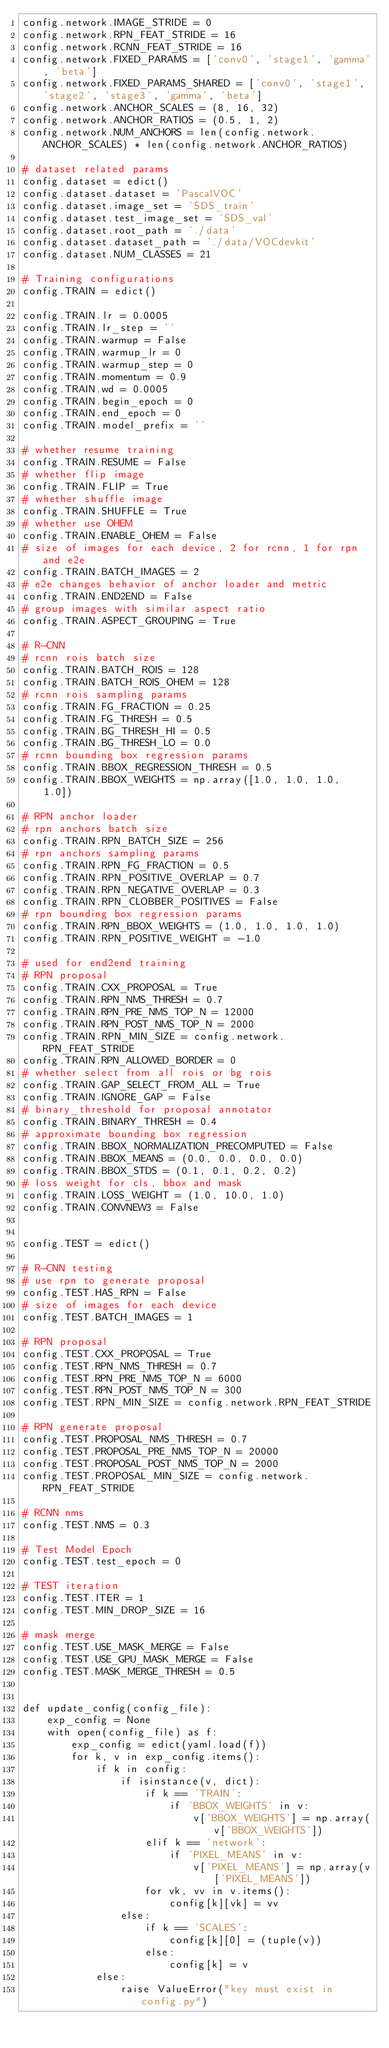<code> <loc_0><loc_0><loc_500><loc_500><_Python_>config.network.IMAGE_STRIDE = 0
config.network.RPN_FEAT_STRIDE = 16
config.network.RCNN_FEAT_STRIDE = 16
config.network.FIXED_PARAMS = ['conv0', 'stage1', 'gamma', 'beta']
config.network.FIXED_PARAMS_SHARED = ['conv0', 'stage1', 'stage2', 'stage3', 'gamma', 'beta']
config.network.ANCHOR_SCALES = (8, 16, 32)
config.network.ANCHOR_RATIOS = (0.5, 1, 2)
config.network.NUM_ANCHORS = len(config.network.ANCHOR_SCALES) * len(config.network.ANCHOR_RATIOS)

# dataset related params
config.dataset = edict()
config.dataset.dataset = 'PascalVOC'
config.dataset.image_set = 'SDS_train'
config.dataset.test_image_set = 'SDS_val'
config.dataset.root_path = './data'
config.dataset.dataset_path = './data/VOCdevkit'
config.dataset.NUM_CLASSES = 21

# Training configurations
config.TRAIN = edict()

config.TRAIN.lr = 0.0005
config.TRAIN.lr_step = ''
config.TRAIN.warmup = False
config.TRAIN.warmup_lr = 0
config.TRAIN.warmup_step = 0
config.TRAIN.momentum = 0.9
config.TRAIN.wd = 0.0005
config.TRAIN.begin_epoch = 0
config.TRAIN.end_epoch = 0
config.TRAIN.model_prefix = ''

# whether resume training
config.TRAIN.RESUME = False
# whether flip image
config.TRAIN.FLIP = True
# whether shuffle image
config.TRAIN.SHUFFLE = True
# whether use OHEM
config.TRAIN.ENABLE_OHEM = False
# size of images for each device, 2 for rcnn, 1 for rpn and e2e
config.TRAIN.BATCH_IMAGES = 2
# e2e changes behavior of anchor loader and metric
config.TRAIN.END2END = False
# group images with similar aspect ratio
config.TRAIN.ASPECT_GROUPING = True

# R-CNN
# rcnn rois batch size
config.TRAIN.BATCH_ROIS = 128
config.TRAIN.BATCH_ROIS_OHEM = 128
# rcnn rois sampling params
config.TRAIN.FG_FRACTION = 0.25
config.TRAIN.FG_THRESH = 0.5
config.TRAIN.BG_THRESH_HI = 0.5
config.TRAIN.BG_THRESH_LO = 0.0
# rcnn bounding box regression params
config.TRAIN.BBOX_REGRESSION_THRESH = 0.5
config.TRAIN.BBOX_WEIGHTS = np.array([1.0, 1.0, 1.0, 1.0])

# RPN anchor loader
# rpn anchors batch size
config.TRAIN.RPN_BATCH_SIZE = 256
# rpn anchors sampling params
config.TRAIN.RPN_FG_FRACTION = 0.5
config.TRAIN.RPN_POSITIVE_OVERLAP = 0.7
config.TRAIN.RPN_NEGATIVE_OVERLAP = 0.3
config.TRAIN.RPN_CLOBBER_POSITIVES = False
# rpn bounding box regression params
config.TRAIN.RPN_BBOX_WEIGHTS = (1.0, 1.0, 1.0, 1.0)
config.TRAIN.RPN_POSITIVE_WEIGHT = -1.0

# used for end2end training
# RPN proposal
config.TRAIN.CXX_PROPOSAL = True
config.TRAIN.RPN_NMS_THRESH = 0.7
config.TRAIN.RPN_PRE_NMS_TOP_N = 12000
config.TRAIN.RPN_POST_NMS_TOP_N = 2000
config.TRAIN.RPN_MIN_SIZE = config.network.RPN_FEAT_STRIDE
config.TRAIN.RPN_ALLOWED_BORDER = 0
# whether select from all rois or bg rois
config.TRAIN.GAP_SELECT_FROM_ALL = True
config.TRAIN.IGNORE_GAP = False
# binary_threshold for proposal annotator
config.TRAIN.BINARY_THRESH = 0.4
# approximate bounding box regression
config.TRAIN.BBOX_NORMALIZATION_PRECOMPUTED = False
config.TRAIN.BBOX_MEANS = (0.0, 0.0, 0.0, 0.0)
config.TRAIN.BBOX_STDS = (0.1, 0.1, 0.2, 0.2)
# loss weight for cls, bbox and mask
config.TRAIN.LOSS_WEIGHT = (1.0, 10.0, 1.0)
config.TRAIN.CONVNEW3 = False


config.TEST = edict()

# R-CNN testing
# use rpn to generate proposal
config.TEST.HAS_RPN = False
# size of images for each device
config.TEST.BATCH_IMAGES = 1

# RPN proposal
config.TEST.CXX_PROPOSAL = True
config.TEST.RPN_NMS_THRESH = 0.7
config.TEST.RPN_PRE_NMS_TOP_N = 6000
config.TEST.RPN_POST_NMS_TOP_N = 300
config.TEST.RPN_MIN_SIZE = config.network.RPN_FEAT_STRIDE

# RPN generate proposal
config.TEST.PROPOSAL_NMS_THRESH = 0.7
config.TEST.PROPOSAL_PRE_NMS_TOP_N = 20000
config.TEST.PROPOSAL_POST_NMS_TOP_N = 2000
config.TEST.PROPOSAL_MIN_SIZE = config.network.RPN_FEAT_STRIDE

# RCNN nms
config.TEST.NMS = 0.3

# Test Model Epoch
config.TEST.test_epoch = 0

# TEST iteration
config.TEST.ITER = 1
config.TEST.MIN_DROP_SIZE = 16

# mask merge
config.TEST.USE_MASK_MERGE = False
config.TEST.USE_GPU_MASK_MERGE = False
config.TEST.MASK_MERGE_THRESH = 0.5


def update_config(config_file):
    exp_config = None
    with open(config_file) as f:
        exp_config = edict(yaml.load(f))
        for k, v in exp_config.items():
            if k in config:
                if isinstance(v, dict):
                    if k == 'TRAIN':
                        if 'BBOX_WEIGHTS' in v:
                            v['BBOX_WEIGHTS'] = np.array(v['BBOX_WEIGHTS'])
                    elif k == 'network':
                        if 'PIXEL_MEANS' in v:
                            v['PIXEL_MEANS'] = np.array(v['PIXEL_MEANS'])
                    for vk, vv in v.items():
                        config[k][vk] = vv
                else:
                    if k == 'SCALES':
                        config[k][0] = (tuple(v))
                    else:
                        config[k] = v
            else:
                raise ValueError("key must exist in config.py")
</code> 